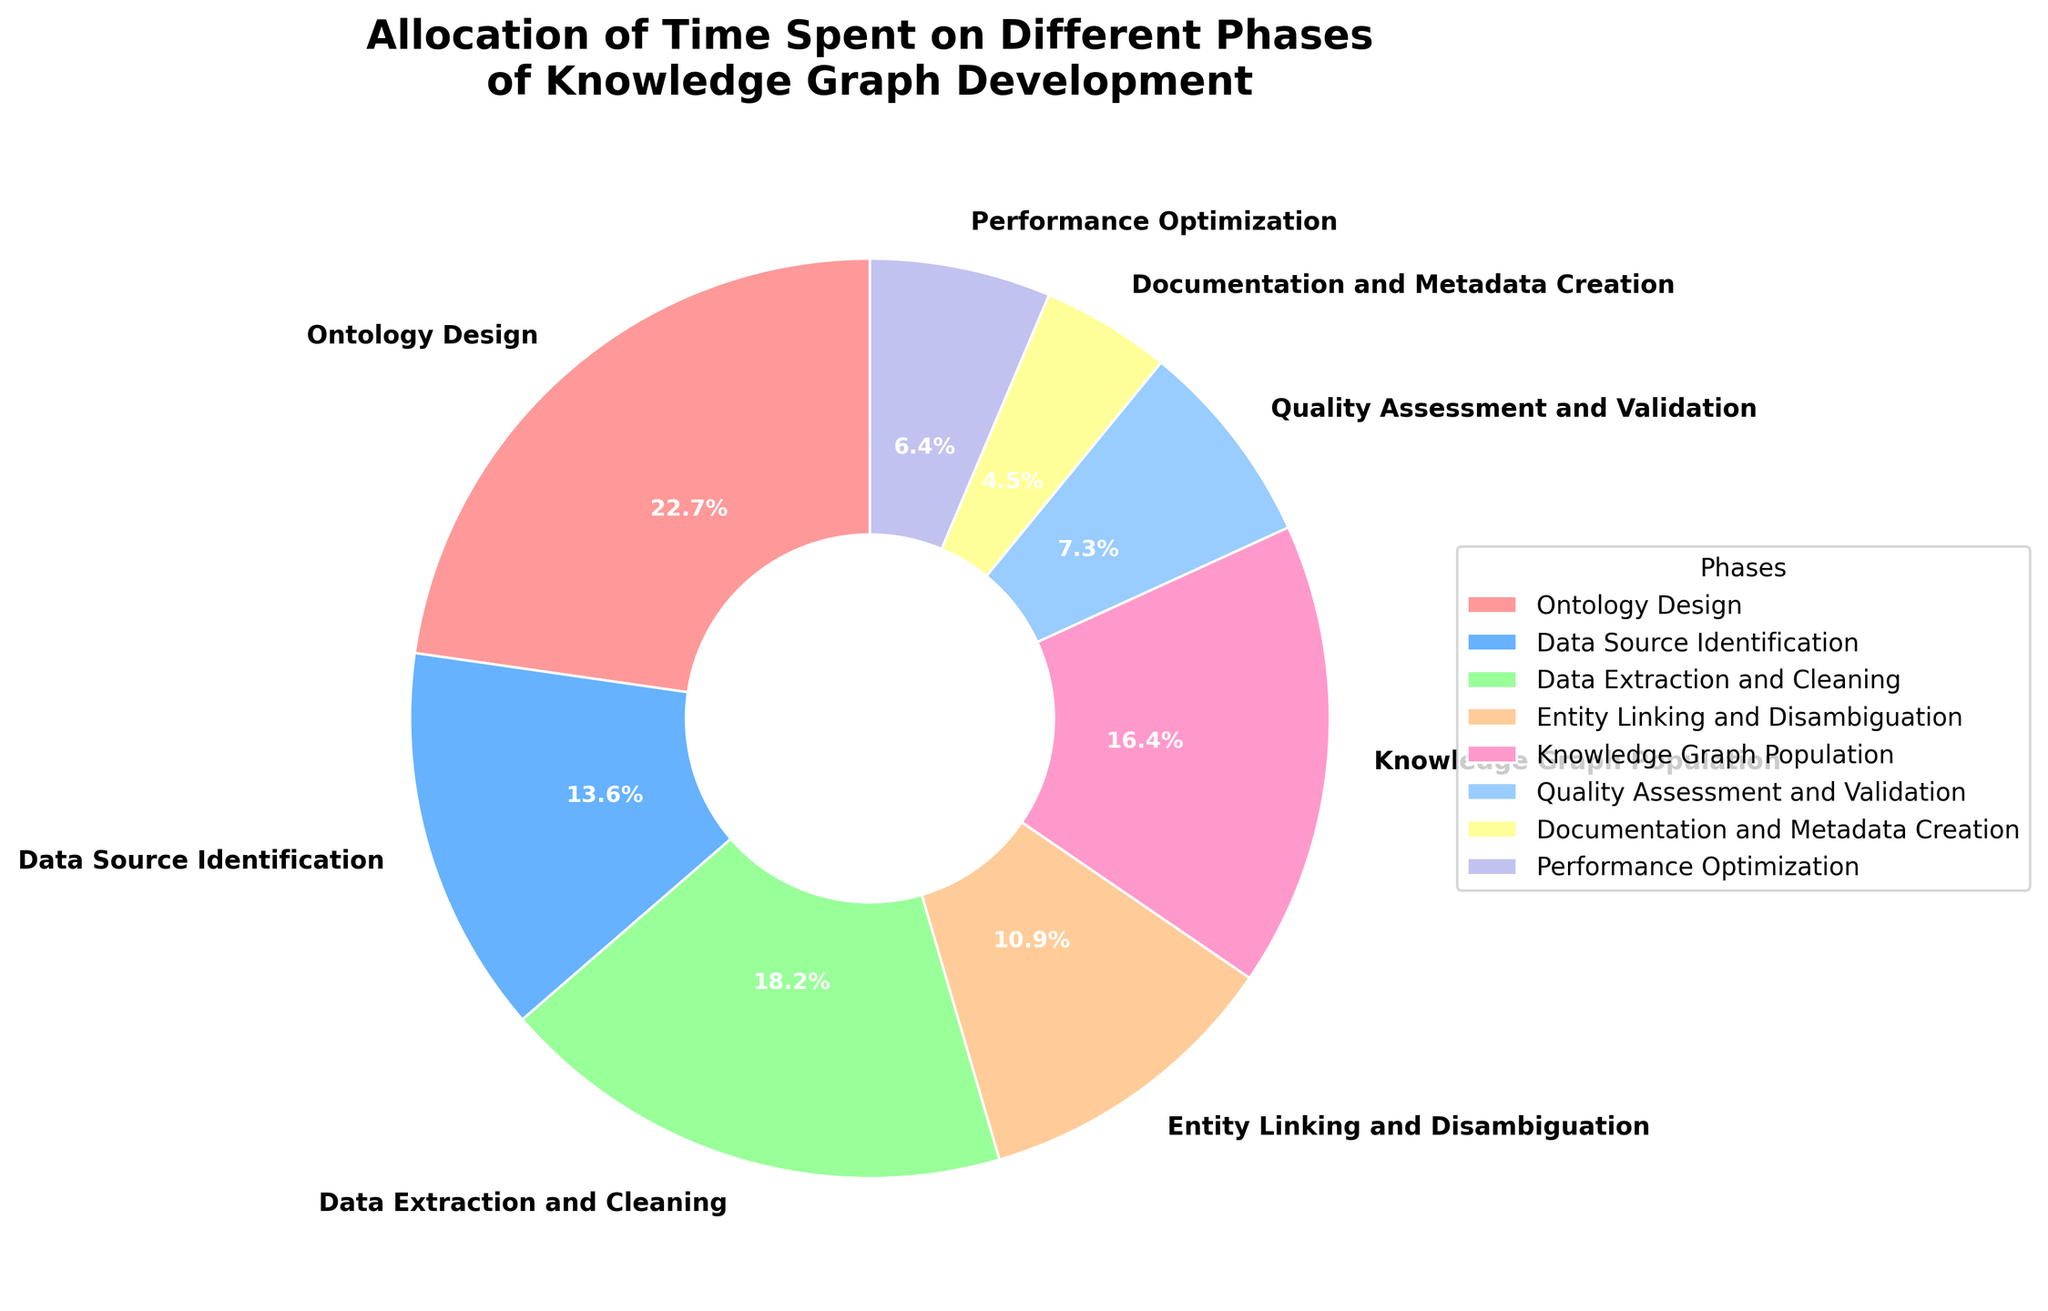what is the highest percentage phase in the knowledge graph development? To determine this, look at the pie chart and identify the largest segment. The segment labeled "Ontology Design" stands out as the largest, and its percentage is 25%.
Answer: Ontology Design with 25% what are the combined percentages of Data Extraction and Cleaning, and Knowledge Graph Population? Add the percentages of both phases: Data Extraction and Cleaning (20%) + Knowledge Graph Population (18%) = 38%
Answer: 38% which phase takes the least amount of time? Look for the smallest segment in the pie chart. The segment "Documentation and Metadata Creation" is the smallest, with a percentage of 5%.
Answer: Documentation and Metadata Creation with 5% how much more time is spent on Ontology Design compared to Entity Linking and Disambiguation? Subtract the percentage of Entity Linking and Disambiguation from Ontology Design: 25% (Ontology Design) - 12% (Entity Linking and Disambiguation) = 13%
Answer: 13% which phases combined account for more than 50% of the time allocation? Sum up the percentages in descending order until you exceed 50%. Ontology Design (25%) + Data Extraction and Cleaning (20%) + Knowledge Graph Population (18%) = 63% > 50%
Answer: Ontology Design, Data Extraction and Cleaning, Knowledge Graph Population which phase is represented by the green segment in the pie chart? Identify green in the pie chart and match it with its label. The green segment corresponds to "Data Source Identification" at 15%.
Answer: Data Source Identification with 15% what is the average percentage allocated to Data Source Identification, Entity Linking and Disambiguation, and Performance Optimization? Average is calculated by summing these percentages and dividing by the number of items: (15% + 12% + 7%) / 3 = 34% / 3 ≈ 11.33%
Answer: 11.33% are there more phases with percentages above or below 10%? Count the number of phases for both categories: Above 10%: Ontology Design, Data Source Identification, Data Extraction and Cleaning, Knowledge Graph Population, Entity Linking and Disambiguation (5 phases). Below 10%: Quality Assessment and Validation, Documentation and Metadata Creation, Performance Optimization (3 phases).
Answer: More phases above 10% how much total time is spent on phases that are below 10% each? Sum the percentages of phases below 10%. Quality Assessment and Validation (8%) + Documentation and Metadata Creation (5%) + Performance Optimization (7%) = 20%
Answer: 20% 